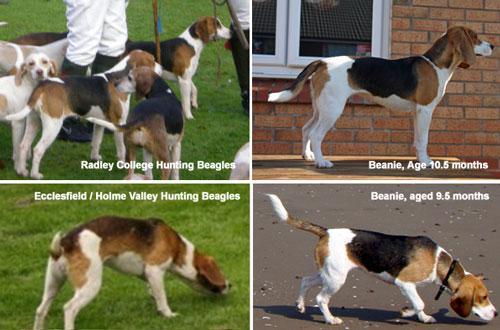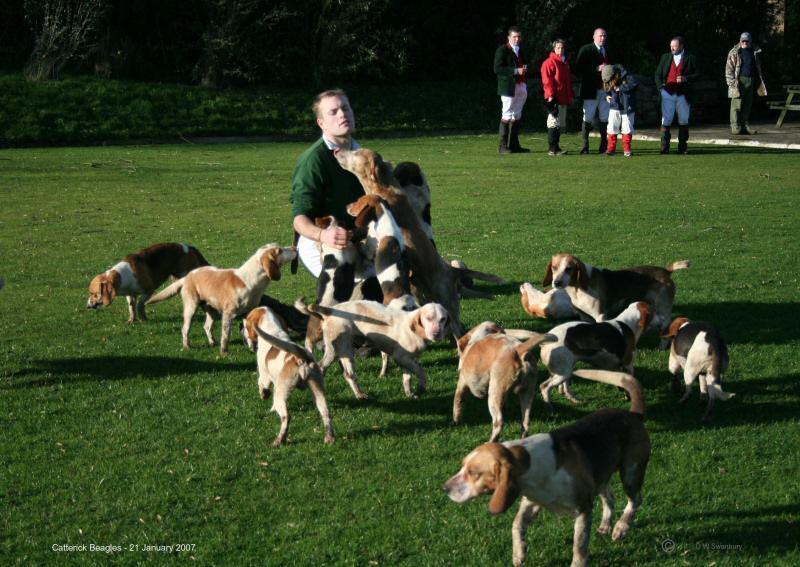The first image is the image on the left, the second image is the image on the right. Given the left and right images, does the statement "At least one horse is present with a group of hounds in one image." hold true? Answer yes or no. No. The first image is the image on the left, the second image is the image on the right. Analyze the images presented: Is the assertion "A horse is in a grassy area with a group of dogs." valid? Answer yes or no. No. 